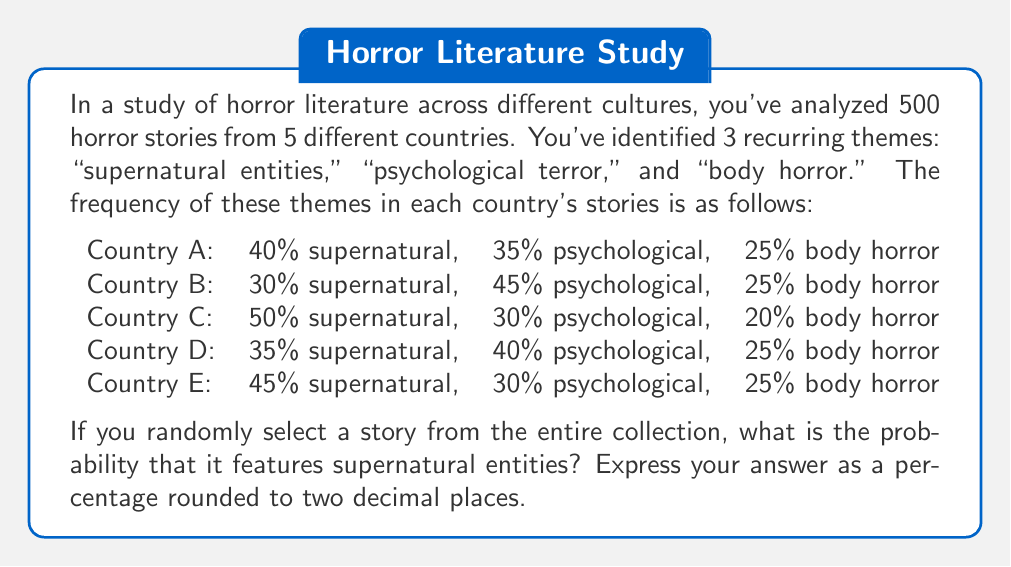Solve this math problem. To solve this problem, we need to calculate the weighted average of the supernatural theme across all countries. Here's how we can approach it:

1. First, we need to determine how many stories are from each country. Since there are 500 stories total and 5 countries, we can assume an equal distribution of 100 stories per country.

2. Now, let's calculate the number of supernatural stories for each country:

   Country A: $100 \times 0.40 = 40$ stories
   Country B: $100 \times 0.30 = 30$ stories
   Country C: $100 \times 0.50 = 50$ stories
   Country D: $100 \times 0.35 = 35$ stories
   Country E: $100 \times 0.45 = 45$ stories

3. Next, we sum up all the supernatural stories:

   $40 + 30 + 50 + 35 + 45 = 200$ supernatural stories

4. To find the probability, we divide the number of supernatural stories by the total number of stories:

   $$P(\text{supernatural}) = \frac{\text{number of supernatural stories}}{\text{total number of stories}} = \frac{200}{500} = 0.4$$

5. Convert to a percentage:

   $0.4 \times 100\% = 40\%$

Therefore, the probability of randomly selecting a story featuring supernatural entities from the entire collection is 40.00%.
Answer: 40.00% 